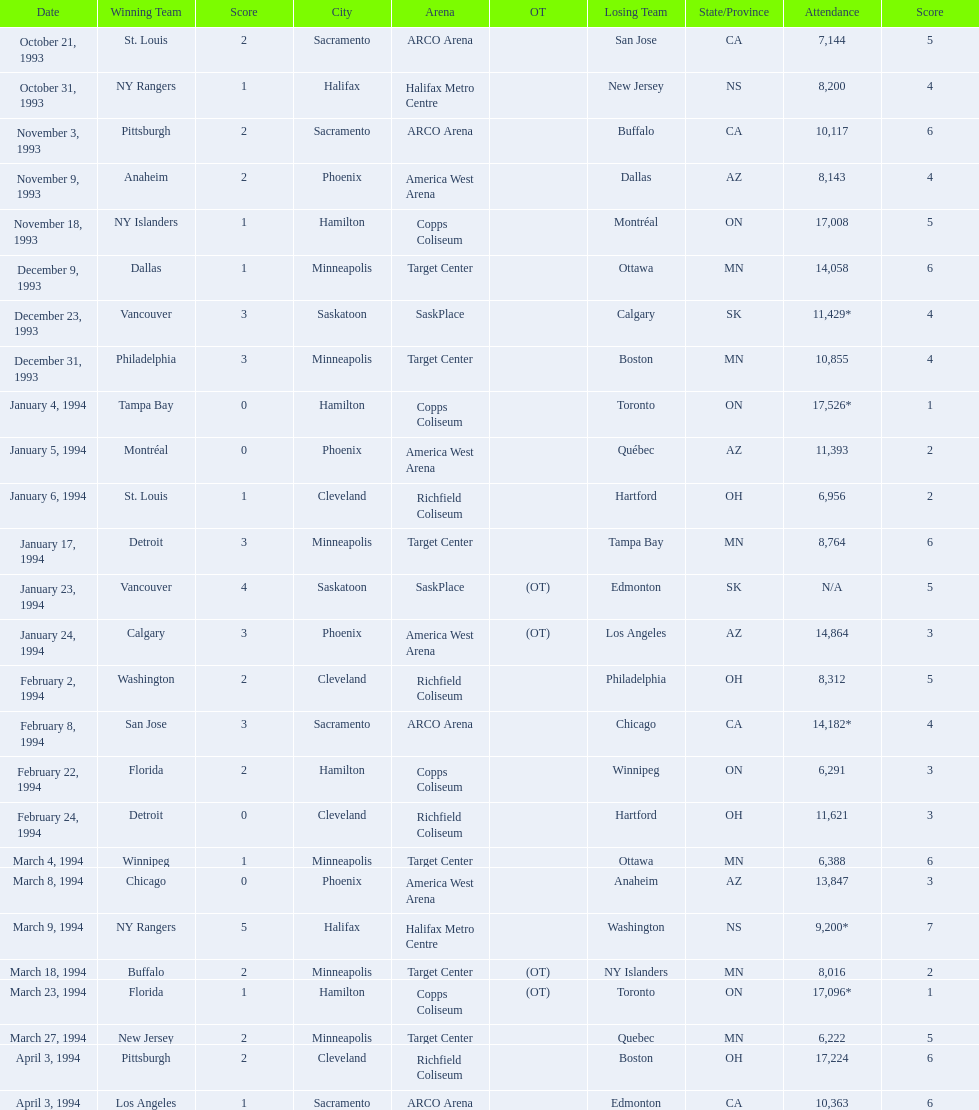On which dates were all the games? October 21, 1993, October 31, 1993, November 3, 1993, November 9, 1993, November 18, 1993, December 9, 1993, December 23, 1993, December 31, 1993, January 4, 1994, January 5, 1994, January 6, 1994, January 17, 1994, January 23, 1994, January 24, 1994, February 2, 1994, February 8, 1994, February 22, 1994, February 24, 1994, March 4, 1994, March 8, 1994, March 9, 1994, March 18, 1994, March 23, 1994, March 27, 1994, April 3, 1994, April 3, 1994. What were the attendances? 7,144, 8,200, 10,117, 8,143, 17,008, 14,058, 11,429*, 10,855, 17,526*, 11,393, 6,956, 8,764, N/A, 14,864, 8,312, 14,182*, 6,291, 11,621, 6,388, 13,847, 9,200*, 8,016, 17,096*, 6,222, 17,224, 10,363. And between december 23, 1993 and january 24, 1994, which game had the highest turnout? January 4, 1994. 